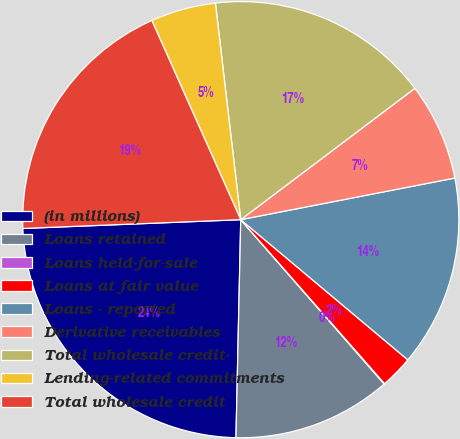Convert chart to OTSL. <chart><loc_0><loc_0><loc_500><loc_500><pie_chart><fcel>(in millions)<fcel>Loans retained<fcel>Loans held-for-sale<fcel>Loans at fair value<fcel>Loans - reported<fcel>Derivative receivables<fcel>Total wholesale credit-<fcel>Lending-related commitments<fcel>Total wholesale credit<nl><fcel>24.01%<fcel>11.77%<fcel>0.04%<fcel>2.43%<fcel>14.17%<fcel>7.23%<fcel>16.57%<fcel>4.83%<fcel>18.96%<nl></chart> 